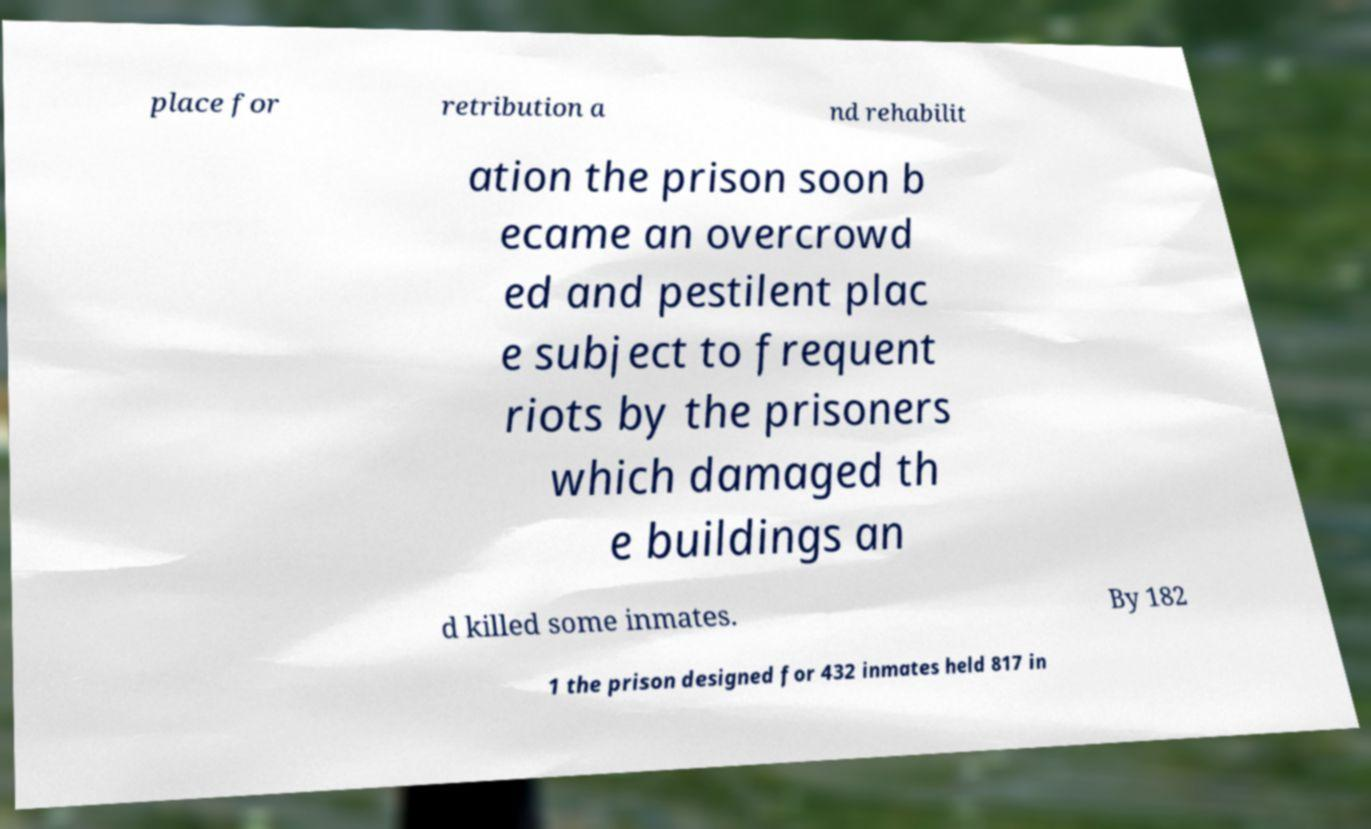Please identify and transcribe the text found in this image. place for retribution a nd rehabilit ation the prison soon b ecame an overcrowd ed and pestilent plac e subject to frequent riots by the prisoners which damaged th e buildings an d killed some inmates. By 182 1 the prison designed for 432 inmates held 817 in 